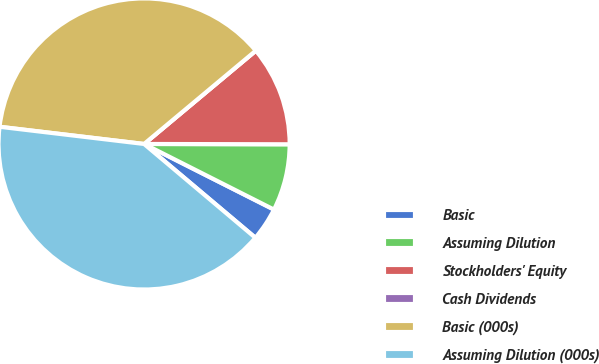Convert chart to OTSL. <chart><loc_0><loc_0><loc_500><loc_500><pie_chart><fcel>Basic<fcel>Assuming Dilution<fcel>Stockholders' Equity<fcel>Cash Dividends<fcel>Basic (000s)<fcel>Assuming Dilution (000s)<nl><fcel>3.7%<fcel>7.41%<fcel>11.11%<fcel>0.0%<fcel>37.04%<fcel>40.74%<nl></chart> 